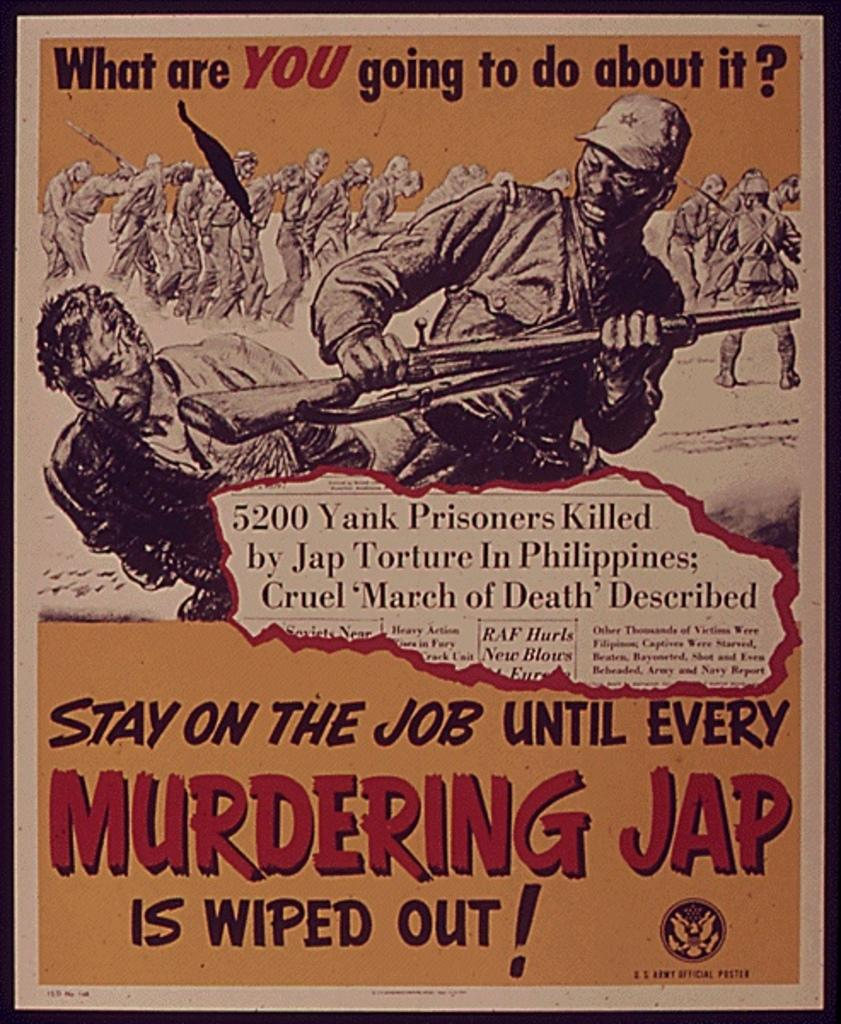What is present on the poster in the image? There is a poster in the image. What can be seen on the poster besides the poster itself? There is text written on the poster and sketches drawn on the poster. How many chairs are visible in the image? There is no chair present in the image; it only features a poster with text and sketches. Is there a window visible in the image? There is no window present in the image; it only features a poster with text and sketches. 